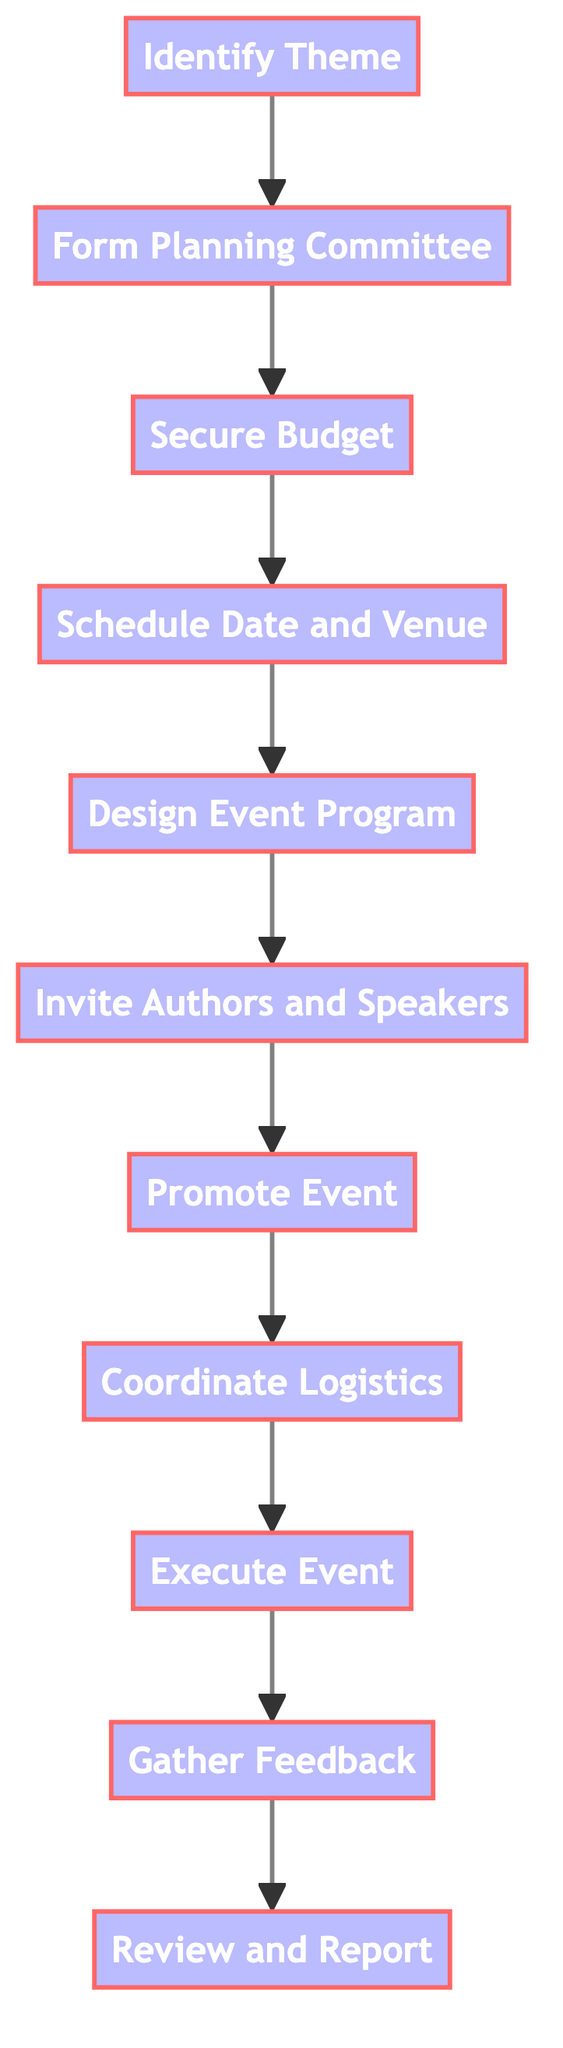What is the first step in the workflow? The first step listed in the diagram is "Identify Theme". This is clearly indicated as the starting point of the flowchart, where the process begins.
Answer: Identify Theme How many steps are in the workflow? By counting the steps represented in the flowchart, there are a total of eleven distinct steps from identifying the theme to reviewing and reporting.
Answer: Eleven What is the last step in the workflow? The last step is "Review and Report," which concludes the process after gathering feedback. This is the final action in the sequence shown in the diagram.
Answer: Review and Report Which step comes immediately after "Secure Budget"? Following "Secure Budget" in the diagram is "Schedule Date and Venue." The connections made by the arrows indicate the direct sequence of steps.
Answer: Schedule Date and Venue What kinds of activities are outlined in "Design Event Program"? The events described in "Design Event Program" include author readings, panel discussions, workshops, and book signings. This is detailed in the information for that step.
Answer: Author readings, panel discussions, workshops, book signings What is the role of the "Planning Committee"? The "Planning Committee" is intended to assemble a team of librarians and volunteers who have an interest in the selected theme, as noted in the details of that specific step.
Answer: Assemble a team of librarians and volunteers Which steps involve interactions with authors? The steps that involve interactions with authors are "Invite Authors and Speakers" and "Execute Event." These steps indicate the specific points where authors are engaged.
Answer: Invite Authors and Speakers, Execute Event What is essential for the coordination of logistics? The coordination of logistics requires arranging for necessary equipment, seating, refreshments, and volunteer staffing, as stated in the related step's details.
Answer: Necessary equipment, seating, refreshments, volunteer staffing What is the purpose of gathering feedback? The purpose of gathering feedback is to collect participant feedback through surveys or comment cards, as indicated in the workflow. This helps evaluate the event's success.
Answer: Collect participant feedback through surveys or comment cards 